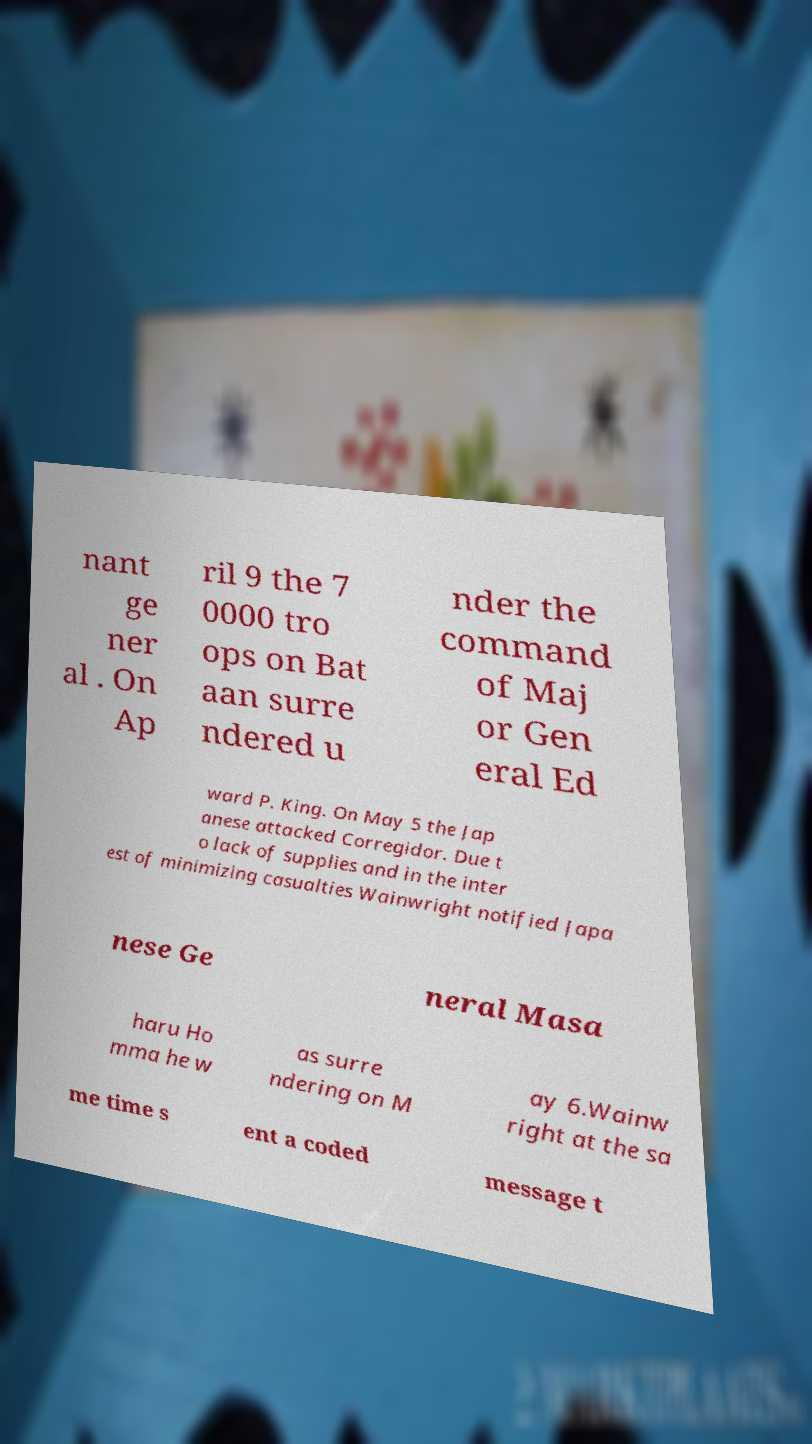Could you extract and type out the text from this image? nant ge ner al . On Ap ril 9 the 7 0000 tro ops on Bat aan surre ndered u nder the command of Maj or Gen eral Ed ward P. King. On May 5 the Jap anese attacked Corregidor. Due t o lack of supplies and in the inter est of minimizing casualties Wainwright notified Japa nese Ge neral Masa haru Ho mma he w as surre ndering on M ay 6.Wainw right at the sa me time s ent a coded message t 